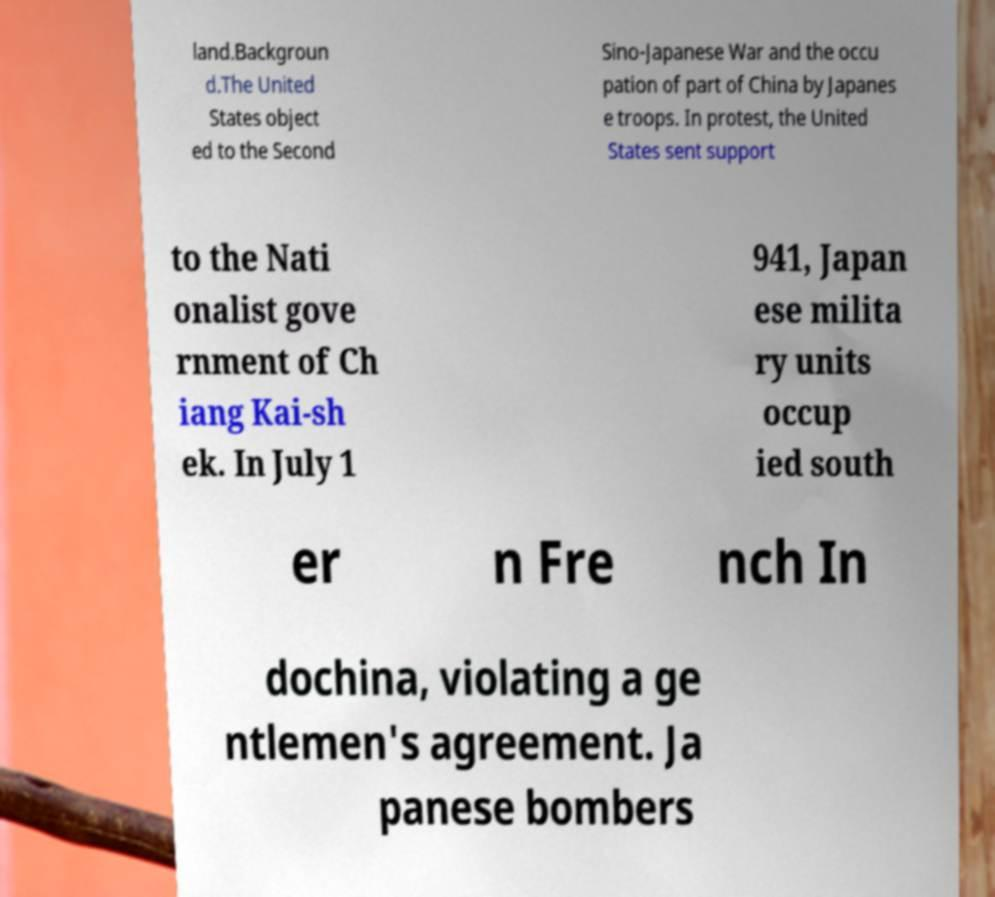Could you extract and type out the text from this image? land.Backgroun d.The United States object ed to the Second Sino-Japanese War and the occu pation of part of China by Japanes e troops. In protest, the United States sent support to the Nati onalist gove rnment of Ch iang Kai-sh ek. In July 1 941, Japan ese milita ry units occup ied south er n Fre nch In dochina, violating a ge ntlemen's agreement. Ja panese bombers 